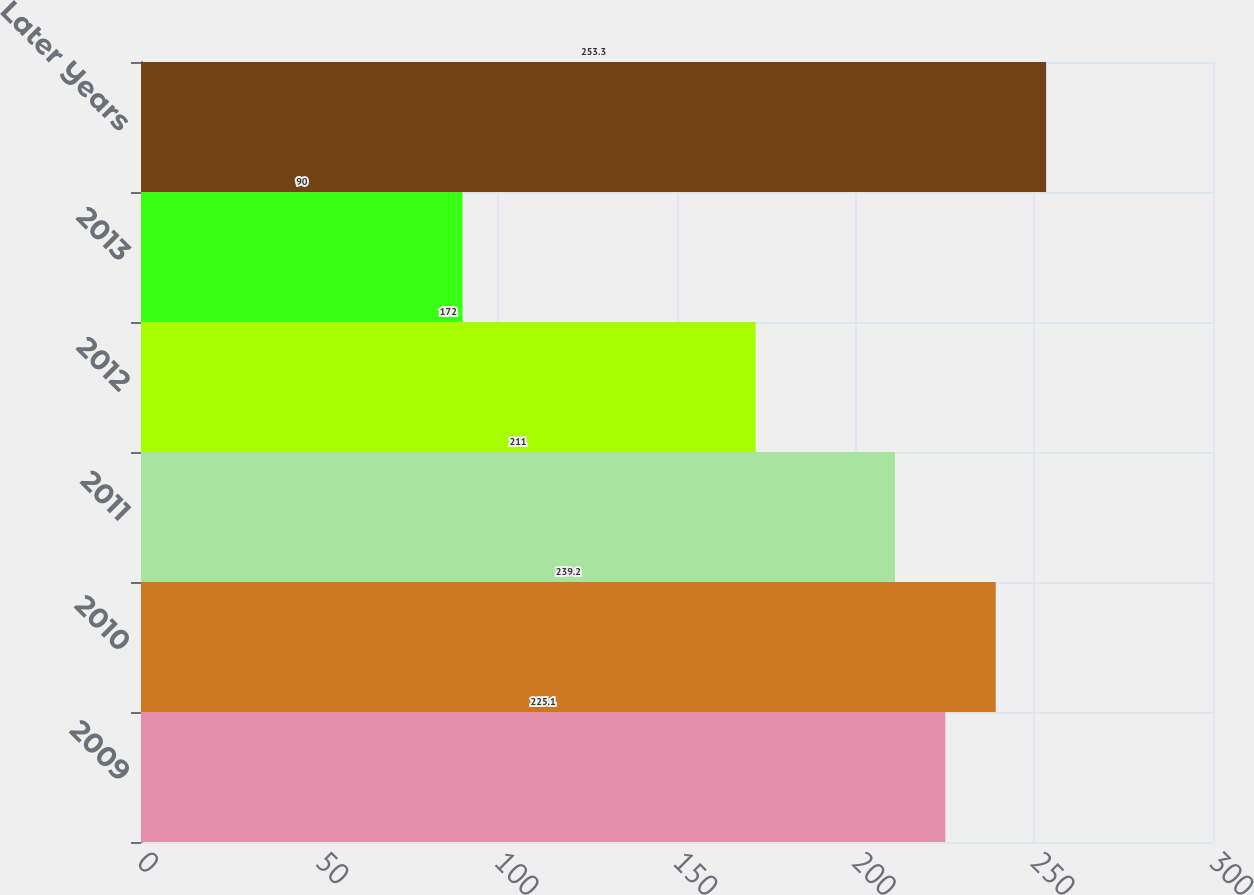Convert chart to OTSL. <chart><loc_0><loc_0><loc_500><loc_500><bar_chart><fcel>2009<fcel>2010<fcel>2011<fcel>2012<fcel>2013<fcel>Later Years<nl><fcel>225.1<fcel>239.2<fcel>211<fcel>172<fcel>90<fcel>253.3<nl></chart> 